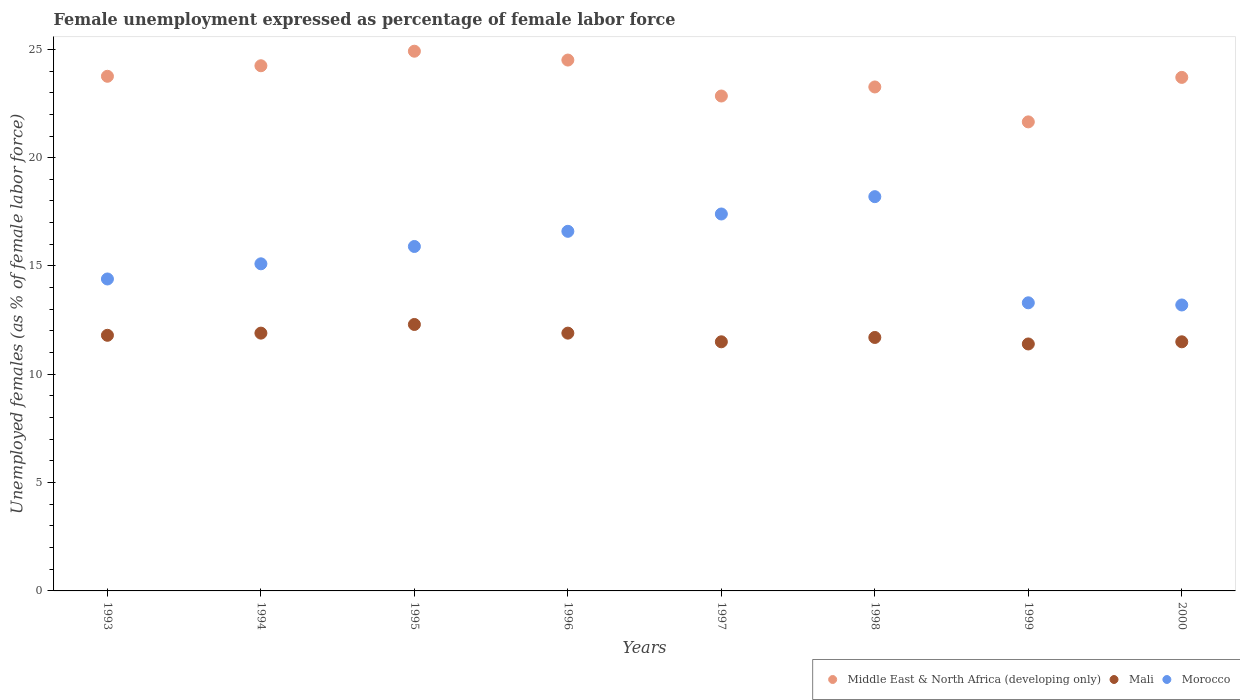How many different coloured dotlines are there?
Provide a succinct answer. 3. Is the number of dotlines equal to the number of legend labels?
Keep it short and to the point. Yes. What is the unemployment in females in in Morocco in 1993?
Make the answer very short. 14.4. Across all years, what is the maximum unemployment in females in in Middle East & North Africa (developing only)?
Give a very brief answer. 24.91. Across all years, what is the minimum unemployment in females in in Morocco?
Make the answer very short. 13.2. What is the total unemployment in females in in Morocco in the graph?
Ensure brevity in your answer.  124.1. What is the difference between the unemployment in females in in Morocco in 1993 and that in 2000?
Your answer should be very brief. 1.2. What is the difference between the unemployment in females in in Morocco in 1994 and the unemployment in females in in Middle East & North Africa (developing only) in 1996?
Ensure brevity in your answer.  -9.41. What is the average unemployment in females in in Middle East & North Africa (developing only) per year?
Give a very brief answer. 23.61. In the year 1996, what is the difference between the unemployment in females in in Mali and unemployment in females in in Middle East & North Africa (developing only)?
Your response must be concise. -12.61. What is the ratio of the unemployment in females in in Mali in 1996 to that in 1998?
Offer a very short reply. 1.02. Is the unemployment in females in in Middle East & North Africa (developing only) in 1994 less than that in 2000?
Ensure brevity in your answer.  No. Is the difference between the unemployment in females in in Mali in 1997 and 2000 greater than the difference between the unemployment in females in in Middle East & North Africa (developing only) in 1997 and 2000?
Keep it short and to the point. Yes. What is the difference between the highest and the second highest unemployment in females in in Morocco?
Your response must be concise. 0.8. What is the difference between the highest and the lowest unemployment in females in in Mali?
Make the answer very short. 0.9. How many dotlines are there?
Ensure brevity in your answer.  3. What is the difference between two consecutive major ticks on the Y-axis?
Your answer should be compact. 5. How many legend labels are there?
Your answer should be compact. 3. What is the title of the graph?
Offer a very short reply. Female unemployment expressed as percentage of female labor force. Does "Thailand" appear as one of the legend labels in the graph?
Offer a very short reply. No. What is the label or title of the Y-axis?
Provide a succinct answer. Unemployed females (as % of female labor force). What is the Unemployed females (as % of female labor force) in Middle East & North Africa (developing only) in 1993?
Your answer should be very brief. 23.76. What is the Unemployed females (as % of female labor force) in Mali in 1993?
Your answer should be compact. 11.8. What is the Unemployed females (as % of female labor force) of Morocco in 1993?
Ensure brevity in your answer.  14.4. What is the Unemployed females (as % of female labor force) of Middle East & North Africa (developing only) in 1994?
Provide a succinct answer. 24.24. What is the Unemployed females (as % of female labor force) in Mali in 1994?
Provide a succinct answer. 11.9. What is the Unemployed females (as % of female labor force) in Morocco in 1994?
Provide a succinct answer. 15.1. What is the Unemployed females (as % of female labor force) of Middle East & North Africa (developing only) in 1995?
Provide a short and direct response. 24.91. What is the Unemployed females (as % of female labor force) of Mali in 1995?
Your response must be concise. 12.3. What is the Unemployed females (as % of female labor force) in Morocco in 1995?
Make the answer very short. 15.9. What is the Unemployed females (as % of female labor force) of Middle East & North Africa (developing only) in 1996?
Ensure brevity in your answer.  24.51. What is the Unemployed females (as % of female labor force) of Mali in 1996?
Give a very brief answer. 11.9. What is the Unemployed females (as % of female labor force) in Morocco in 1996?
Provide a short and direct response. 16.6. What is the Unemployed females (as % of female labor force) of Middle East & North Africa (developing only) in 1997?
Your response must be concise. 22.85. What is the Unemployed females (as % of female labor force) of Morocco in 1997?
Make the answer very short. 17.4. What is the Unemployed females (as % of female labor force) in Middle East & North Africa (developing only) in 1998?
Ensure brevity in your answer.  23.26. What is the Unemployed females (as % of female labor force) of Mali in 1998?
Your response must be concise. 11.7. What is the Unemployed females (as % of female labor force) of Morocco in 1998?
Make the answer very short. 18.2. What is the Unemployed females (as % of female labor force) of Middle East & North Africa (developing only) in 1999?
Provide a succinct answer. 21.65. What is the Unemployed females (as % of female labor force) of Mali in 1999?
Your response must be concise. 11.4. What is the Unemployed females (as % of female labor force) of Morocco in 1999?
Offer a very short reply. 13.3. What is the Unemployed females (as % of female labor force) in Middle East & North Africa (developing only) in 2000?
Your answer should be very brief. 23.71. What is the Unemployed females (as % of female labor force) of Mali in 2000?
Ensure brevity in your answer.  11.5. What is the Unemployed females (as % of female labor force) in Morocco in 2000?
Provide a short and direct response. 13.2. Across all years, what is the maximum Unemployed females (as % of female labor force) in Middle East & North Africa (developing only)?
Make the answer very short. 24.91. Across all years, what is the maximum Unemployed females (as % of female labor force) in Mali?
Make the answer very short. 12.3. Across all years, what is the maximum Unemployed females (as % of female labor force) in Morocco?
Your response must be concise. 18.2. Across all years, what is the minimum Unemployed females (as % of female labor force) in Middle East & North Africa (developing only)?
Ensure brevity in your answer.  21.65. Across all years, what is the minimum Unemployed females (as % of female labor force) in Mali?
Keep it short and to the point. 11.4. Across all years, what is the minimum Unemployed females (as % of female labor force) in Morocco?
Provide a short and direct response. 13.2. What is the total Unemployed females (as % of female labor force) of Middle East & North Africa (developing only) in the graph?
Ensure brevity in your answer.  188.89. What is the total Unemployed females (as % of female labor force) in Mali in the graph?
Your answer should be very brief. 94. What is the total Unemployed females (as % of female labor force) in Morocco in the graph?
Your response must be concise. 124.1. What is the difference between the Unemployed females (as % of female labor force) in Middle East & North Africa (developing only) in 1993 and that in 1994?
Offer a very short reply. -0.49. What is the difference between the Unemployed females (as % of female labor force) of Morocco in 1993 and that in 1994?
Give a very brief answer. -0.7. What is the difference between the Unemployed females (as % of female labor force) of Middle East & North Africa (developing only) in 1993 and that in 1995?
Ensure brevity in your answer.  -1.16. What is the difference between the Unemployed females (as % of female labor force) in Morocco in 1993 and that in 1995?
Your response must be concise. -1.5. What is the difference between the Unemployed females (as % of female labor force) of Middle East & North Africa (developing only) in 1993 and that in 1996?
Your answer should be compact. -0.75. What is the difference between the Unemployed females (as % of female labor force) in Morocco in 1993 and that in 1996?
Offer a terse response. -2.2. What is the difference between the Unemployed females (as % of female labor force) of Middle East & North Africa (developing only) in 1993 and that in 1997?
Give a very brief answer. 0.91. What is the difference between the Unemployed females (as % of female labor force) in Mali in 1993 and that in 1997?
Give a very brief answer. 0.3. What is the difference between the Unemployed females (as % of female labor force) of Morocco in 1993 and that in 1997?
Your answer should be compact. -3. What is the difference between the Unemployed females (as % of female labor force) in Middle East & North Africa (developing only) in 1993 and that in 1998?
Keep it short and to the point. 0.49. What is the difference between the Unemployed females (as % of female labor force) in Mali in 1993 and that in 1998?
Give a very brief answer. 0.1. What is the difference between the Unemployed females (as % of female labor force) of Middle East & North Africa (developing only) in 1993 and that in 1999?
Your answer should be very brief. 2.1. What is the difference between the Unemployed females (as % of female labor force) in Middle East & North Africa (developing only) in 1993 and that in 2000?
Offer a terse response. 0.05. What is the difference between the Unemployed females (as % of female labor force) of Middle East & North Africa (developing only) in 1994 and that in 1995?
Provide a short and direct response. -0.67. What is the difference between the Unemployed females (as % of female labor force) of Mali in 1994 and that in 1995?
Ensure brevity in your answer.  -0.4. What is the difference between the Unemployed females (as % of female labor force) in Morocco in 1994 and that in 1995?
Your answer should be compact. -0.8. What is the difference between the Unemployed females (as % of female labor force) in Middle East & North Africa (developing only) in 1994 and that in 1996?
Give a very brief answer. -0.26. What is the difference between the Unemployed females (as % of female labor force) of Mali in 1994 and that in 1996?
Give a very brief answer. 0. What is the difference between the Unemployed females (as % of female labor force) of Morocco in 1994 and that in 1996?
Your response must be concise. -1.5. What is the difference between the Unemployed females (as % of female labor force) of Middle East & North Africa (developing only) in 1994 and that in 1997?
Offer a very short reply. 1.4. What is the difference between the Unemployed females (as % of female labor force) in Morocco in 1994 and that in 1997?
Offer a terse response. -2.3. What is the difference between the Unemployed females (as % of female labor force) of Middle East & North Africa (developing only) in 1994 and that in 1998?
Make the answer very short. 0.98. What is the difference between the Unemployed females (as % of female labor force) in Mali in 1994 and that in 1998?
Your response must be concise. 0.2. What is the difference between the Unemployed females (as % of female labor force) of Middle East & North Africa (developing only) in 1994 and that in 1999?
Give a very brief answer. 2.59. What is the difference between the Unemployed females (as % of female labor force) of Middle East & North Africa (developing only) in 1994 and that in 2000?
Give a very brief answer. 0.54. What is the difference between the Unemployed females (as % of female labor force) of Mali in 1994 and that in 2000?
Give a very brief answer. 0.4. What is the difference between the Unemployed females (as % of female labor force) in Morocco in 1994 and that in 2000?
Keep it short and to the point. 1.9. What is the difference between the Unemployed females (as % of female labor force) in Middle East & North Africa (developing only) in 1995 and that in 1996?
Ensure brevity in your answer.  0.41. What is the difference between the Unemployed females (as % of female labor force) of Middle East & North Africa (developing only) in 1995 and that in 1997?
Your response must be concise. 2.07. What is the difference between the Unemployed females (as % of female labor force) of Morocco in 1995 and that in 1997?
Make the answer very short. -1.5. What is the difference between the Unemployed females (as % of female labor force) in Middle East & North Africa (developing only) in 1995 and that in 1998?
Provide a succinct answer. 1.65. What is the difference between the Unemployed females (as % of female labor force) in Mali in 1995 and that in 1998?
Make the answer very short. 0.6. What is the difference between the Unemployed females (as % of female labor force) of Middle East & North Africa (developing only) in 1995 and that in 1999?
Provide a succinct answer. 3.26. What is the difference between the Unemployed females (as % of female labor force) of Middle East & North Africa (developing only) in 1995 and that in 2000?
Offer a very short reply. 1.21. What is the difference between the Unemployed females (as % of female labor force) of Middle East & North Africa (developing only) in 1996 and that in 1997?
Provide a succinct answer. 1.66. What is the difference between the Unemployed females (as % of female labor force) in Mali in 1996 and that in 1997?
Your response must be concise. 0.4. What is the difference between the Unemployed females (as % of female labor force) of Middle East & North Africa (developing only) in 1996 and that in 1998?
Provide a short and direct response. 1.24. What is the difference between the Unemployed females (as % of female labor force) in Mali in 1996 and that in 1998?
Give a very brief answer. 0.2. What is the difference between the Unemployed females (as % of female labor force) of Morocco in 1996 and that in 1998?
Offer a terse response. -1.6. What is the difference between the Unemployed females (as % of female labor force) of Middle East & North Africa (developing only) in 1996 and that in 1999?
Provide a succinct answer. 2.85. What is the difference between the Unemployed females (as % of female labor force) in Morocco in 1996 and that in 1999?
Your answer should be compact. 3.3. What is the difference between the Unemployed females (as % of female labor force) in Mali in 1996 and that in 2000?
Offer a very short reply. 0.4. What is the difference between the Unemployed females (as % of female labor force) of Morocco in 1996 and that in 2000?
Give a very brief answer. 3.4. What is the difference between the Unemployed females (as % of female labor force) in Middle East & North Africa (developing only) in 1997 and that in 1998?
Offer a very short reply. -0.42. What is the difference between the Unemployed females (as % of female labor force) of Morocco in 1997 and that in 1998?
Offer a very short reply. -0.8. What is the difference between the Unemployed females (as % of female labor force) of Middle East & North Africa (developing only) in 1997 and that in 1999?
Offer a terse response. 1.19. What is the difference between the Unemployed females (as % of female labor force) of Mali in 1997 and that in 1999?
Your answer should be compact. 0.1. What is the difference between the Unemployed females (as % of female labor force) in Morocco in 1997 and that in 1999?
Make the answer very short. 4.1. What is the difference between the Unemployed females (as % of female labor force) in Middle East & North Africa (developing only) in 1997 and that in 2000?
Offer a very short reply. -0.86. What is the difference between the Unemployed females (as % of female labor force) in Mali in 1997 and that in 2000?
Provide a short and direct response. 0. What is the difference between the Unemployed females (as % of female labor force) of Middle East & North Africa (developing only) in 1998 and that in 1999?
Your answer should be very brief. 1.61. What is the difference between the Unemployed females (as % of female labor force) in Mali in 1998 and that in 1999?
Provide a short and direct response. 0.3. What is the difference between the Unemployed females (as % of female labor force) of Middle East & North Africa (developing only) in 1998 and that in 2000?
Provide a succinct answer. -0.44. What is the difference between the Unemployed females (as % of female labor force) in Middle East & North Africa (developing only) in 1999 and that in 2000?
Make the answer very short. -2.05. What is the difference between the Unemployed females (as % of female labor force) in Morocco in 1999 and that in 2000?
Provide a succinct answer. 0.1. What is the difference between the Unemployed females (as % of female labor force) of Middle East & North Africa (developing only) in 1993 and the Unemployed females (as % of female labor force) of Mali in 1994?
Keep it short and to the point. 11.86. What is the difference between the Unemployed females (as % of female labor force) of Middle East & North Africa (developing only) in 1993 and the Unemployed females (as % of female labor force) of Morocco in 1994?
Make the answer very short. 8.66. What is the difference between the Unemployed females (as % of female labor force) of Middle East & North Africa (developing only) in 1993 and the Unemployed females (as % of female labor force) of Mali in 1995?
Make the answer very short. 11.46. What is the difference between the Unemployed females (as % of female labor force) of Middle East & North Africa (developing only) in 1993 and the Unemployed females (as % of female labor force) of Morocco in 1995?
Provide a succinct answer. 7.86. What is the difference between the Unemployed females (as % of female labor force) of Mali in 1993 and the Unemployed females (as % of female labor force) of Morocco in 1995?
Keep it short and to the point. -4.1. What is the difference between the Unemployed females (as % of female labor force) of Middle East & North Africa (developing only) in 1993 and the Unemployed females (as % of female labor force) of Mali in 1996?
Keep it short and to the point. 11.86. What is the difference between the Unemployed females (as % of female labor force) of Middle East & North Africa (developing only) in 1993 and the Unemployed females (as % of female labor force) of Morocco in 1996?
Provide a succinct answer. 7.16. What is the difference between the Unemployed females (as % of female labor force) in Middle East & North Africa (developing only) in 1993 and the Unemployed females (as % of female labor force) in Mali in 1997?
Your answer should be compact. 12.26. What is the difference between the Unemployed females (as % of female labor force) in Middle East & North Africa (developing only) in 1993 and the Unemployed females (as % of female labor force) in Morocco in 1997?
Offer a terse response. 6.36. What is the difference between the Unemployed females (as % of female labor force) of Middle East & North Africa (developing only) in 1993 and the Unemployed females (as % of female labor force) of Mali in 1998?
Offer a terse response. 12.06. What is the difference between the Unemployed females (as % of female labor force) in Middle East & North Africa (developing only) in 1993 and the Unemployed females (as % of female labor force) in Morocco in 1998?
Your answer should be compact. 5.56. What is the difference between the Unemployed females (as % of female labor force) of Mali in 1993 and the Unemployed females (as % of female labor force) of Morocco in 1998?
Offer a terse response. -6.4. What is the difference between the Unemployed females (as % of female labor force) of Middle East & North Africa (developing only) in 1993 and the Unemployed females (as % of female labor force) of Mali in 1999?
Keep it short and to the point. 12.36. What is the difference between the Unemployed females (as % of female labor force) of Middle East & North Africa (developing only) in 1993 and the Unemployed females (as % of female labor force) of Morocco in 1999?
Provide a succinct answer. 10.46. What is the difference between the Unemployed females (as % of female labor force) in Middle East & North Africa (developing only) in 1993 and the Unemployed females (as % of female labor force) in Mali in 2000?
Your answer should be compact. 12.26. What is the difference between the Unemployed females (as % of female labor force) of Middle East & North Africa (developing only) in 1993 and the Unemployed females (as % of female labor force) of Morocco in 2000?
Offer a very short reply. 10.56. What is the difference between the Unemployed females (as % of female labor force) in Mali in 1993 and the Unemployed females (as % of female labor force) in Morocco in 2000?
Give a very brief answer. -1.4. What is the difference between the Unemployed females (as % of female labor force) of Middle East & North Africa (developing only) in 1994 and the Unemployed females (as % of female labor force) of Mali in 1995?
Your answer should be compact. 11.94. What is the difference between the Unemployed females (as % of female labor force) in Middle East & North Africa (developing only) in 1994 and the Unemployed females (as % of female labor force) in Morocco in 1995?
Offer a very short reply. 8.34. What is the difference between the Unemployed females (as % of female labor force) in Middle East & North Africa (developing only) in 1994 and the Unemployed females (as % of female labor force) in Mali in 1996?
Make the answer very short. 12.34. What is the difference between the Unemployed females (as % of female labor force) of Middle East & North Africa (developing only) in 1994 and the Unemployed females (as % of female labor force) of Morocco in 1996?
Your answer should be compact. 7.64. What is the difference between the Unemployed females (as % of female labor force) in Middle East & North Africa (developing only) in 1994 and the Unemployed females (as % of female labor force) in Mali in 1997?
Ensure brevity in your answer.  12.74. What is the difference between the Unemployed females (as % of female labor force) of Middle East & North Africa (developing only) in 1994 and the Unemployed females (as % of female labor force) of Morocco in 1997?
Your response must be concise. 6.84. What is the difference between the Unemployed females (as % of female labor force) in Mali in 1994 and the Unemployed females (as % of female labor force) in Morocco in 1997?
Give a very brief answer. -5.5. What is the difference between the Unemployed females (as % of female labor force) of Middle East & North Africa (developing only) in 1994 and the Unemployed females (as % of female labor force) of Mali in 1998?
Offer a very short reply. 12.54. What is the difference between the Unemployed females (as % of female labor force) of Middle East & North Africa (developing only) in 1994 and the Unemployed females (as % of female labor force) of Morocco in 1998?
Offer a very short reply. 6.04. What is the difference between the Unemployed females (as % of female labor force) in Mali in 1994 and the Unemployed females (as % of female labor force) in Morocco in 1998?
Your response must be concise. -6.3. What is the difference between the Unemployed females (as % of female labor force) of Middle East & North Africa (developing only) in 1994 and the Unemployed females (as % of female labor force) of Mali in 1999?
Provide a succinct answer. 12.84. What is the difference between the Unemployed females (as % of female labor force) of Middle East & North Africa (developing only) in 1994 and the Unemployed females (as % of female labor force) of Morocco in 1999?
Make the answer very short. 10.94. What is the difference between the Unemployed females (as % of female labor force) of Middle East & North Africa (developing only) in 1994 and the Unemployed females (as % of female labor force) of Mali in 2000?
Provide a short and direct response. 12.74. What is the difference between the Unemployed females (as % of female labor force) in Middle East & North Africa (developing only) in 1994 and the Unemployed females (as % of female labor force) in Morocco in 2000?
Offer a terse response. 11.04. What is the difference between the Unemployed females (as % of female labor force) of Middle East & North Africa (developing only) in 1995 and the Unemployed females (as % of female labor force) of Mali in 1996?
Provide a succinct answer. 13.01. What is the difference between the Unemployed females (as % of female labor force) in Middle East & North Africa (developing only) in 1995 and the Unemployed females (as % of female labor force) in Morocco in 1996?
Keep it short and to the point. 8.31. What is the difference between the Unemployed females (as % of female labor force) of Middle East & North Africa (developing only) in 1995 and the Unemployed females (as % of female labor force) of Mali in 1997?
Keep it short and to the point. 13.41. What is the difference between the Unemployed females (as % of female labor force) of Middle East & North Africa (developing only) in 1995 and the Unemployed females (as % of female labor force) of Morocco in 1997?
Give a very brief answer. 7.51. What is the difference between the Unemployed females (as % of female labor force) of Mali in 1995 and the Unemployed females (as % of female labor force) of Morocco in 1997?
Provide a succinct answer. -5.1. What is the difference between the Unemployed females (as % of female labor force) of Middle East & North Africa (developing only) in 1995 and the Unemployed females (as % of female labor force) of Mali in 1998?
Provide a succinct answer. 13.21. What is the difference between the Unemployed females (as % of female labor force) of Middle East & North Africa (developing only) in 1995 and the Unemployed females (as % of female labor force) of Morocco in 1998?
Your answer should be very brief. 6.71. What is the difference between the Unemployed females (as % of female labor force) in Mali in 1995 and the Unemployed females (as % of female labor force) in Morocco in 1998?
Your answer should be compact. -5.9. What is the difference between the Unemployed females (as % of female labor force) of Middle East & North Africa (developing only) in 1995 and the Unemployed females (as % of female labor force) of Mali in 1999?
Provide a short and direct response. 13.51. What is the difference between the Unemployed females (as % of female labor force) of Middle East & North Africa (developing only) in 1995 and the Unemployed females (as % of female labor force) of Morocco in 1999?
Your answer should be compact. 11.61. What is the difference between the Unemployed females (as % of female labor force) of Mali in 1995 and the Unemployed females (as % of female labor force) of Morocco in 1999?
Offer a very short reply. -1. What is the difference between the Unemployed females (as % of female labor force) in Middle East & North Africa (developing only) in 1995 and the Unemployed females (as % of female labor force) in Mali in 2000?
Give a very brief answer. 13.41. What is the difference between the Unemployed females (as % of female labor force) in Middle East & North Africa (developing only) in 1995 and the Unemployed females (as % of female labor force) in Morocco in 2000?
Ensure brevity in your answer.  11.71. What is the difference between the Unemployed females (as % of female labor force) of Mali in 1995 and the Unemployed females (as % of female labor force) of Morocco in 2000?
Provide a short and direct response. -0.9. What is the difference between the Unemployed females (as % of female labor force) of Middle East & North Africa (developing only) in 1996 and the Unemployed females (as % of female labor force) of Mali in 1997?
Make the answer very short. 13.01. What is the difference between the Unemployed females (as % of female labor force) of Middle East & North Africa (developing only) in 1996 and the Unemployed females (as % of female labor force) of Morocco in 1997?
Give a very brief answer. 7.11. What is the difference between the Unemployed females (as % of female labor force) in Mali in 1996 and the Unemployed females (as % of female labor force) in Morocco in 1997?
Ensure brevity in your answer.  -5.5. What is the difference between the Unemployed females (as % of female labor force) of Middle East & North Africa (developing only) in 1996 and the Unemployed females (as % of female labor force) of Mali in 1998?
Provide a succinct answer. 12.81. What is the difference between the Unemployed females (as % of female labor force) in Middle East & North Africa (developing only) in 1996 and the Unemployed females (as % of female labor force) in Morocco in 1998?
Offer a very short reply. 6.31. What is the difference between the Unemployed females (as % of female labor force) in Middle East & North Africa (developing only) in 1996 and the Unemployed females (as % of female labor force) in Mali in 1999?
Provide a succinct answer. 13.11. What is the difference between the Unemployed females (as % of female labor force) in Middle East & North Africa (developing only) in 1996 and the Unemployed females (as % of female labor force) in Morocco in 1999?
Your answer should be very brief. 11.21. What is the difference between the Unemployed females (as % of female labor force) of Middle East & North Africa (developing only) in 1996 and the Unemployed females (as % of female labor force) of Mali in 2000?
Your answer should be very brief. 13.01. What is the difference between the Unemployed females (as % of female labor force) of Middle East & North Africa (developing only) in 1996 and the Unemployed females (as % of female labor force) of Morocco in 2000?
Your response must be concise. 11.31. What is the difference between the Unemployed females (as % of female labor force) in Mali in 1996 and the Unemployed females (as % of female labor force) in Morocco in 2000?
Give a very brief answer. -1.3. What is the difference between the Unemployed females (as % of female labor force) in Middle East & North Africa (developing only) in 1997 and the Unemployed females (as % of female labor force) in Mali in 1998?
Provide a short and direct response. 11.15. What is the difference between the Unemployed females (as % of female labor force) of Middle East & North Africa (developing only) in 1997 and the Unemployed females (as % of female labor force) of Morocco in 1998?
Ensure brevity in your answer.  4.65. What is the difference between the Unemployed females (as % of female labor force) in Middle East & North Africa (developing only) in 1997 and the Unemployed females (as % of female labor force) in Mali in 1999?
Offer a very short reply. 11.45. What is the difference between the Unemployed females (as % of female labor force) in Middle East & North Africa (developing only) in 1997 and the Unemployed females (as % of female labor force) in Morocco in 1999?
Your response must be concise. 9.55. What is the difference between the Unemployed females (as % of female labor force) in Mali in 1997 and the Unemployed females (as % of female labor force) in Morocco in 1999?
Give a very brief answer. -1.8. What is the difference between the Unemployed females (as % of female labor force) of Middle East & North Africa (developing only) in 1997 and the Unemployed females (as % of female labor force) of Mali in 2000?
Offer a terse response. 11.35. What is the difference between the Unemployed females (as % of female labor force) in Middle East & North Africa (developing only) in 1997 and the Unemployed females (as % of female labor force) in Morocco in 2000?
Your answer should be compact. 9.65. What is the difference between the Unemployed females (as % of female labor force) in Middle East & North Africa (developing only) in 1998 and the Unemployed females (as % of female labor force) in Mali in 1999?
Offer a terse response. 11.86. What is the difference between the Unemployed females (as % of female labor force) of Middle East & North Africa (developing only) in 1998 and the Unemployed females (as % of female labor force) of Morocco in 1999?
Your response must be concise. 9.96. What is the difference between the Unemployed females (as % of female labor force) in Middle East & North Africa (developing only) in 1998 and the Unemployed females (as % of female labor force) in Mali in 2000?
Give a very brief answer. 11.76. What is the difference between the Unemployed females (as % of female labor force) of Middle East & North Africa (developing only) in 1998 and the Unemployed females (as % of female labor force) of Morocco in 2000?
Offer a very short reply. 10.06. What is the difference between the Unemployed females (as % of female labor force) of Middle East & North Africa (developing only) in 1999 and the Unemployed females (as % of female labor force) of Mali in 2000?
Offer a very short reply. 10.15. What is the difference between the Unemployed females (as % of female labor force) of Middle East & North Africa (developing only) in 1999 and the Unemployed females (as % of female labor force) of Morocco in 2000?
Your response must be concise. 8.45. What is the difference between the Unemployed females (as % of female labor force) of Mali in 1999 and the Unemployed females (as % of female labor force) of Morocco in 2000?
Provide a short and direct response. -1.8. What is the average Unemployed females (as % of female labor force) of Middle East & North Africa (developing only) per year?
Provide a succinct answer. 23.61. What is the average Unemployed females (as % of female labor force) in Mali per year?
Give a very brief answer. 11.75. What is the average Unemployed females (as % of female labor force) in Morocco per year?
Provide a short and direct response. 15.51. In the year 1993, what is the difference between the Unemployed females (as % of female labor force) of Middle East & North Africa (developing only) and Unemployed females (as % of female labor force) of Mali?
Your response must be concise. 11.96. In the year 1993, what is the difference between the Unemployed females (as % of female labor force) of Middle East & North Africa (developing only) and Unemployed females (as % of female labor force) of Morocco?
Ensure brevity in your answer.  9.36. In the year 1994, what is the difference between the Unemployed females (as % of female labor force) of Middle East & North Africa (developing only) and Unemployed females (as % of female labor force) of Mali?
Keep it short and to the point. 12.34. In the year 1994, what is the difference between the Unemployed females (as % of female labor force) of Middle East & North Africa (developing only) and Unemployed females (as % of female labor force) of Morocco?
Give a very brief answer. 9.14. In the year 1994, what is the difference between the Unemployed females (as % of female labor force) of Mali and Unemployed females (as % of female labor force) of Morocco?
Give a very brief answer. -3.2. In the year 1995, what is the difference between the Unemployed females (as % of female labor force) in Middle East & North Africa (developing only) and Unemployed females (as % of female labor force) in Mali?
Provide a succinct answer. 12.61. In the year 1995, what is the difference between the Unemployed females (as % of female labor force) in Middle East & North Africa (developing only) and Unemployed females (as % of female labor force) in Morocco?
Your answer should be very brief. 9.01. In the year 1995, what is the difference between the Unemployed females (as % of female labor force) in Mali and Unemployed females (as % of female labor force) in Morocco?
Provide a short and direct response. -3.6. In the year 1996, what is the difference between the Unemployed females (as % of female labor force) in Middle East & North Africa (developing only) and Unemployed females (as % of female labor force) in Mali?
Provide a short and direct response. 12.61. In the year 1996, what is the difference between the Unemployed females (as % of female labor force) in Middle East & North Africa (developing only) and Unemployed females (as % of female labor force) in Morocco?
Give a very brief answer. 7.91. In the year 1996, what is the difference between the Unemployed females (as % of female labor force) of Mali and Unemployed females (as % of female labor force) of Morocco?
Provide a short and direct response. -4.7. In the year 1997, what is the difference between the Unemployed females (as % of female labor force) of Middle East & North Africa (developing only) and Unemployed females (as % of female labor force) of Mali?
Offer a terse response. 11.35. In the year 1997, what is the difference between the Unemployed females (as % of female labor force) of Middle East & North Africa (developing only) and Unemployed females (as % of female labor force) of Morocco?
Give a very brief answer. 5.45. In the year 1997, what is the difference between the Unemployed females (as % of female labor force) of Mali and Unemployed females (as % of female labor force) of Morocco?
Make the answer very short. -5.9. In the year 1998, what is the difference between the Unemployed females (as % of female labor force) of Middle East & North Africa (developing only) and Unemployed females (as % of female labor force) of Mali?
Your answer should be compact. 11.56. In the year 1998, what is the difference between the Unemployed females (as % of female labor force) of Middle East & North Africa (developing only) and Unemployed females (as % of female labor force) of Morocco?
Ensure brevity in your answer.  5.06. In the year 1999, what is the difference between the Unemployed females (as % of female labor force) of Middle East & North Africa (developing only) and Unemployed females (as % of female labor force) of Mali?
Provide a succinct answer. 10.25. In the year 1999, what is the difference between the Unemployed females (as % of female labor force) of Middle East & North Africa (developing only) and Unemployed females (as % of female labor force) of Morocco?
Ensure brevity in your answer.  8.35. In the year 1999, what is the difference between the Unemployed females (as % of female labor force) of Mali and Unemployed females (as % of female labor force) of Morocco?
Your answer should be compact. -1.9. In the year 2000, what is the difference between the Unemployed females (as % of female labor force) of Middle East & North Africa (developing only) and Unemployed females (as % of female labor force) of Mali?
Your response must be concise. 12.21. In the year 2000, what is the difference between the Unemployed females (as % of female labor force) of Middle East & North Africa (developing only) and Unemployed females (as % of female labor force) of Morocco?
Your response must be concise. 10.51. In the year 2000, what is the difference between the Unemployed females (as % of female labor force) in Mali and Unemployed females (as % of female labor force) in Morocco?
Offer a terse response. -1.7. What is the ratio of the Unemployed females (as % of female labor force) of Middle East & North Africa (developing only) in 1993 to that in 1994?
Your answer should be very brief. 0.98. What is the ratio of the Unemployed females (as % of female labor force) of Morocco in 1993 to that in 1994?
Your answer should be compact. 0.95. What is the ratio of the Unemployed females (as % of female labor force) in Middle East & North Africa (developing only) in 1993 to that in 1995?
Offer a terse response. 0.95. What is the ratio of the Unemployed females (as % of female labor force) in Mali in 1993 to that in 1995?
Make the answer very short. 0.96. What is the ratio of the Unemployed females (as % of female labor force) in Morocco in 1993 to that in 1995?
Provide a succinct answer. 0.91. What is the ratio of the Unemployed females (as % of female labor force) of Middle East & North Africa (developing only) in 1993 to that in 1996?
Provide a short and direct response. 0.97. What is the ratio of the Unemployed females (as % of female labor force) of Morocco in 1993 to that in 1996?
Your response must be concise. 0.87. What is the ratio of the Unemployed females (as % of female labor force) in Middle East & North Africa (developing only) in 1993 to that in 1997?
Offer a terse response. 1.04. What is the ratio of the Unemployed females (as % of female labor force) in Mali in 1993 to that in 1997?
Make the answer very short. 1.03. What is the ratio of the Unemployed females (as % of female labor force) in Morocco in 1993 to that in 1997?
Make the answer very short. 0.83. What is the ratio of the Unemployed females (as % of female labor force) in Middle East & North Africa (developing only) in 1993 to that in 1998?
Keep it short and to the point. 1.02. What is the ratio of the Unemployed females (as % of female labor force) of Mali in 1993 to that in 1998?
Keep it short and to the point. 1.01. What is the ratio of the Unemployed females (as % of female labor force) in Morocco in 1993 to that in 1998?
Provide a short and direct response. 0.79. What is the ratio of the Unemployed females (as % of female labor force) in Middle East & North Africa (developing only) in 1993 to that in 1999?
Your response must be concise. 1.1. What is the ratio of the Unemployed females (as % of female labor force) of Mali in 1993 to that in 1999?
Your response must be concise. 1.04. What is the ratio of the Unemployed females (as % of female labor force) of Morocco in 1993 to that in 1999?
Make the answer very short. 1.08. What is the ratio of the Unemployed females (as % of female labor force) in Mali in 1993 to that in 2000?
Make the answer very short. 1.03. What is the ratio of the Unemployed females (as % of female labor force) of Middle East & North Africa (developing only) in 1994 to that in 1995?
Ensure brevity in your answer.  0.97. What is the ratio of the Unemployed females (as % of female labor force) in Mali in 1994 to that in 1995?
Offer a very short reply. 0.97. What is the ratio of the Unemployed females (as % of female labor force) in Morocco in 1994 to that in 1995?
Make the answer very short. 0.95. What is the ratio of the Unemployed females (as % of female labor force) of Middle East & North Africa (developing only) in 1994 to that in 1996?
Provide a succinct answer. 0.99. What is the ratio of the Unemployed females (as % of female labor force) in Morocco in 1994 to that in 1996?
Your answer should be compact. 0.91. What is the ratio of the Unemployed females (as % of female labor force) of Middle East & North Africa (developing only) in 1994 to that in 1997?
Ensure brevity in your answer.  1.06. What is the ratio of the Unemployed females (as % of female labor force) in Mali in 1994 to that in 1997?
Keep it short and to the point. 1.03. What is the ratio of the Unemployed females (as % of female labor force) of Morocco in 1994 to that in 1997?
Your answer should be very brief. 0.87. What is the ratio of the Unemployed females (as % of female labor force) of Middle East & North Africa (developing only) in 1994 to that in 1998?
Your response must be concise. 1.04. What is the ratio of the Unemployed females (as % of female labor force) of Mali in 1994 to that in 1998?
Your response must be concise. 1.02. What is the ratio of the Unemployed females (as % of female labor force) of Morocco in 1994 to that in 1998?
Keep it short and to the point. 0.83. What is the ratio of the Unemployed females (as % of female labor force) in Middle East & North Africa (developing only) in 1994 to that in 1999?
Ensure brevity in your answer.  1.12. What is the ratio of the Unemployed females (as % of female labor force) of Mali in 1994 to that in 1999?
Give a very brief answer. 1.04. What is the ratio of the Unemployed females (as % of female labor force) of Morocco in 1994 to that in 1999?
Your answer should be compact. 1.14. What is the ratio of the Unemployed females (as % of female labor force) of Middle East & North Africa (developing only) in 1994 to that in 2000?
Your answer should be very brief. 1.02. What is the ratio of the Unemployed females (as % of female labor force) of Mali in 1994 to that in 2000?
Offer a terse response. 1.03. What is the ratio of the Unemployed females (as % of female labor force) of Morocco in 1994 to that in 2000?
Provide a short and direct response. 1.14. What is the ratio of the Unemployed females (as % of female labor force) of Middle East & North Africa (developing only) in 1995 to that in 1996?
Provide a short and direct response. 1.02. What is the ratio of the Unemployed females (as % of female labor force) in Mali in 1995 to that in 1996?
Your response must be concise. 1.03. What is the ratio of the Unemployed females (as % of female labor force) in Morocco in 1995 to that in 1996?
Provide a short and direct response. 0.96. What is the ratio of the Unemployed females (as % of female labor force) of Middle East & North Africa (developing only) in 1995 to that in 1997?
Make the answer very short. 1.09. What is the ratio of the Unemployed females (as % of female labor force) of Mali in 1995 to that in 1997?
Provide a short and direct response. 1.07. What is the ratio of the Unemployed females (as % of female labor force) in Morocco in 1995 to that in 1997?
Offer a terse response. 0.91. What is the ratio of the Unemployed females (as % of female labor force) of Middle East & North Africa (developing only) in 1995 to that in 1998?
Provide a succinct answer. 1.07. What is the ratio of the Unemployed females (as % of female labor force) in Mali in 1995 to that in 1998?
Your response must be concise. 1.05. What is the ratio of the Unemployed females (as % of female labor force) in Morocco in 1995 to that in 1998?
Your answer should be very brief. 0.87. What is the ratio of the Unemployed females (as % of female labor force) of Middle East & North Africa (developing only) in 1995 to that in 1999?
Your response must be concise. 1.15. What is the ratio of the Unemployed females (as % of female labor force) in Mali in 1995 to that in 1999?
Your answer should be very brief. 1.08. What is the ratio of the Unemployed females (as % of female labor force) of Morocco in 1995 to that in 1999?
Make the answer very short. 1.2. What is the ratio of the Unemployed females (as % of female labor force) in Middle East & North Africa (developing only) in 1995 to that in 2000?
Your answer should be compact. 1.05. What is the ratio of the Unemployed females (as % of female labor force) of Mali in 1995 to that in 2000?
Make the answer very short. 1.07. What is the ratio of the Unemployed females (as % of female labor force) in Morocco in 1995 to that in 2000?
Keep it short and to the point. 1.2. What is the ratio of the Unemployed females (as % of female labor force) in Middle East & North Africa (developing only) in 1996 to that in 1997?
Ensure brevity in your answer.  1.07. What is the ratio of the Unemployed females (as % of female labor force) of Mali in 1996 to that in 1997?
Provide a succinct answer. 1.03. What is the ratio of the Unemployed females (as % of female labor force) in Morocco in 1996 to that in 1997?
Ensure brevity in your answer.  0.95. What is the ratio of the Unemployed females (as % of female labor force) in Middle East & North Africa (developing only) in 1996 to that in 1998?
Make the answer very short. 1.05. What is the ratio of the Unemployed females (as % of female labor force) of Mali in 1996 to that in 1998?
Offer a very short reply. 1.02. What is the ratio of the Unemployed females (as % of female labor force) in Morocco in 1996 to that in 1998?
Your answer should be compact. 0.91. What is the ratio of the Unemployed females (as % of female labor force) in Middle East & North Africa (developing only) in 1996 to that in 1999?
Your response must be concise. 1.13. What is the ratio of the Unemployed females (as % of female labor force) in Mali in 1996 to that in 1999?
Make the answer very short. 1.04. What is the ratio of the Unemployed females (as % of female labor force) of Morocco in 1996 to that in 1999?
Keep it short and to the point. 1.25. What is the ratio of the Unemployed females (as % of female labor force) of Middle East & North Africa (developing only) in 1996 to that in 2000?
Provide a succinct answer. 1.03. What is the ratio of the Unemployed females (as % of female labor force) of Mali in 1996 to that in 2000?
Offer a very short reply. 1.03. What is the ratio of the Unemployed females (as % of female labor force) of Morocco in 1996 to that in 2000?
Your answer should be very brief. 1.26. What is the ratio of the Unemployed females (as % of female labor force) in Middle East & North Africa (developing only) in 1997 to that in 1998?
Ensure brevity in your answer.  0.98. What is the ratio of the Unemployed females (as % of female labor force) of Mali in 1997 to that in 1998?
Your answer should be compact. 0.98. What is the ratio of the Unemployed females (as % of female labor force) in Morocco in 1997 to that in 1998?
Give a very brief answer. 0.96. What is the ratio of the Unemployed females (as % of female labor force) in Middle East & North Africa (developing only) in 1997 to that in 1999?
Make the answer very short. 1.06. What is the ratio of the Unemployed females (as % of female labor force) of Mali in 1997 to that in 1999?
Offer a very short reply. 1.01. What is the ratio of the Unemployed females (as % of female labor force) of Morocco in 1997 to that in 1999?
Ensure brevity in your answer.  1.31. What is the ratio of the Unemployed females (as % of female labor force) of Middle East & North Africa (developing only) in 1997 to that in 2000?
Your answer should be very brief. 0.96. What is the ratio of the Unemployed females (as % of female labor force) in Mali in 1997 to that in 2000?
Your answer should be compact. 1. What is the ratio of the Unemployed females (as % of female labor force) in Morocco in 1997 to that in 2000?
Give a very brief answer. 1.32. What is the ratio of the Unemployed females (as % of female labor force) of Middle East & North Africa (developing only) in 1998 to that in 1999?
Your answer should be compact. 1.07. What is the ratio of the Unemployed females (as % of female labor force) in Mali in 1998 to that in 1999?
Keep it short and to the point. 1.03. What is the ratio of the Unemployed females (as % of female labor force) in Morocco in 1998 to that in 1999?
Offer a terse response. 1.37. What is the ratio of the Unemployed females (as % of female labor force) of Middle East & North Africa (developing only) in 1998 to that in 2000?
Provide a succinct answer. 0.98. What is the ratio of the Unemployed females (as % of female labor force) of Mali in 1998 to that in 2000?
Offer a terse response. 1.02. What is the ratio of the Unemployed females (as % of female labor force) of Morocco in 1998 to that in 2000?
Your response must be concise. 1.38. What is the ratio of the Unemployed females (as % of female labor force) of Middle East & North Africa (developing only) in 1999 to that in 2000?
Give a very brief answer. 0.91. What is the ratio of the Unemployed females (as % of female labor force) in Morocco in 1999 to that in 2000?
Keep it short and to the point. 1.01. What is the difference between the highest and the second highest Unemployed females (as % of female labor force) of Middle East & North Africa (developing only)?
Provide a succinct answer. 0.41. What is the difference between the highest and the second highest Unemployed females (as % of female labor force) of Morocco?
Make the answer very short. 0.8. What is the difference between the highest and the lowest Unemployed females (as % of female labor force) in Middle East & North Africa (developing only)?
Your response must be concise. 3.26. 